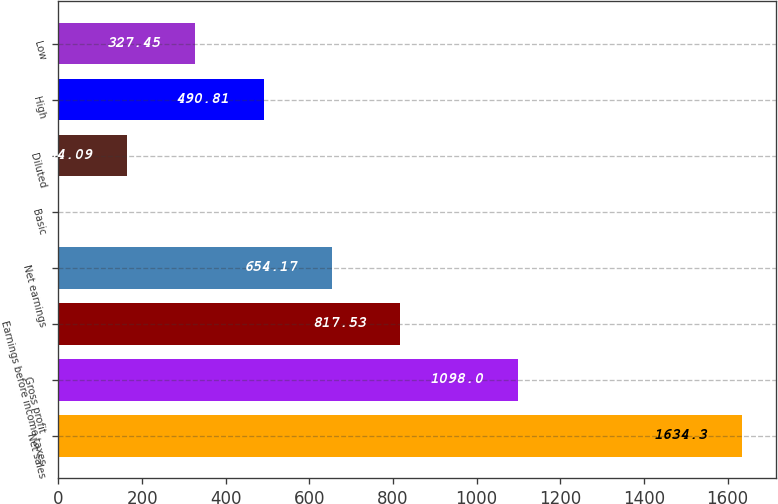Convert chart to OTSL. <chart><loc_0><loc_0><loc_500><loc_500><bar_chart><fcel>Net sales<fcel>Gross profit<fcel>Earnings before income taxes<fcel>Net earnings<fcel>Basic<fcel>Diluted<fcel>High<fcel>Low<nl><fcel>1634.3<fcel>1098<fcel>817.53<fcel>654.17<fcel>0.73<fcel>164.09<fcel>490.81<fcel>327.45<nl></chart> 